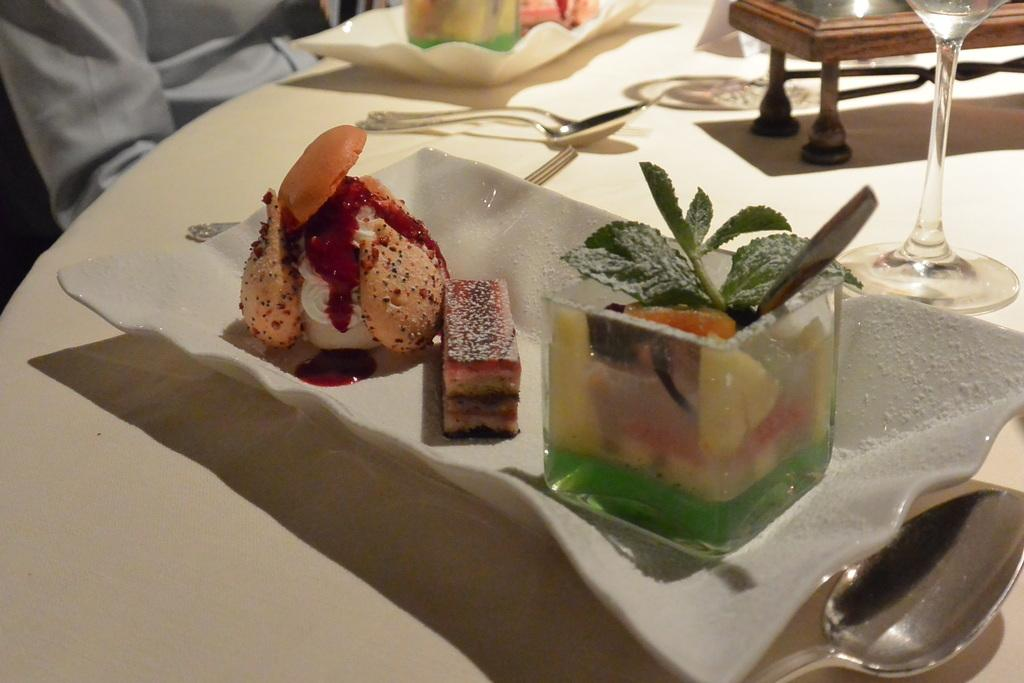What is located in the center of the image? There is a table in the center of the image. What can be found on the table? There are food items on the table, which are on a plate. What utensils are present on the table? There are spoons on the table. What type of container is on the table? There is a glass on the table. Can you describe the person in the background of the image? There is a person in the background of the image, but no specific details are provided about them. How many dimes are visible on the table in the image? There are no dimes visible on the table in the image. Can you see an airplane flying in the background of the image? There is no mention of an airplane in the image, so it cannot be seen. 